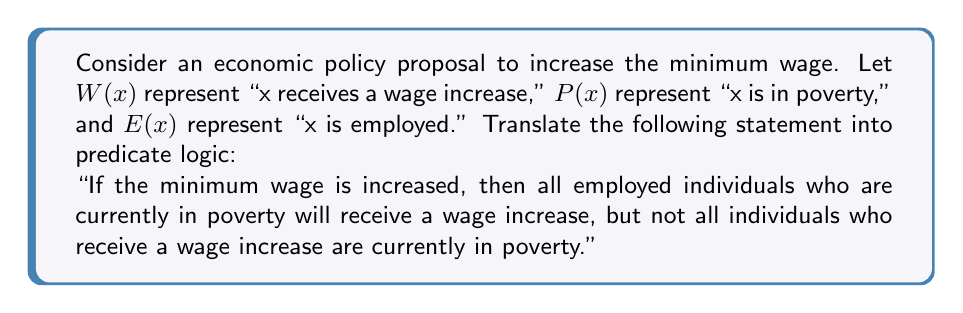Can you answer this question? To translate this statement into predicate logic, we need to break it down into its component parts and use quantifiers and logical connectives. Let's approach this step-by-step:

1. First, we need to represent the condition "If the minimum wage is increased." This is an antecedent for the entire statement, so we'll use the implication symbol ($\rightarrow$) to connect it to the rest of the logic.

2. The first part of the consequent states "all employed individuals who are currently in poverty will receive a wage increase." We can represent this using the universal quantifier ($\forall$) and logical connectives:

   $\forall x ((E(x) \land P(x)) \rightarrow W(x))$

3. The second part states "not all individuals who receive a wage increase are currently in poverty." This is a negation of a universal statement, which can be represented as an existential statement:

   $\exists x (W(x) \land \neg P(x))$

4. We need to combine these two parts using the logical AND ($\land$) operator.

5. Finally, we connect the antecedent (minimum wage increase) to this combined consequent.

Putting it all together, we get:

$$(\text{Minimum wage increased}) \rightarrow [\forall x ((E(x) \land P(x)) \rightarrow W(x)) \land \exists x (W(x) \land \neg P(x))]$$

This logical statement accurately represents the given economic policy proposal in predicate logic.
Answer: $$(\text{Minimum wage increased}) \rightarrow [\forall x ((E(x) \land P(x)) \rightarrow W(x)) \land \exists x (W(x) \land \neg P(x))]$$ 